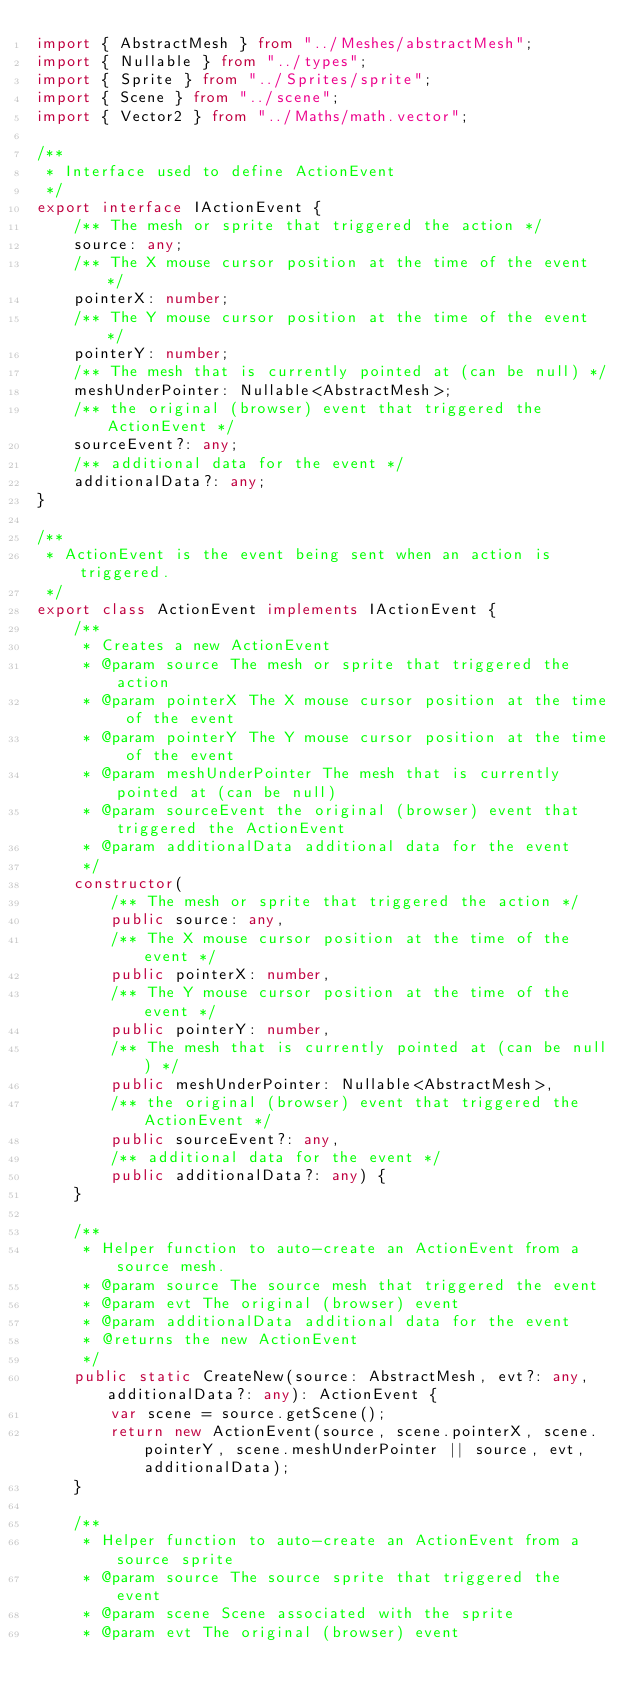Convert code to text. <code><loc_0><loc_0><loc_500><loc_500><_TypeScript_>import { AbstractMesh } from "../Meshes/abstractMesh";
import { Nullable } from "../types";
import { Sprite } from "../Sprites/sprite";
import { Scene } from "../scene";
import { Vector2 } from "../Maths/math.vector";

/**
 * Interface used to define ActionEvent
 */
export interface IActionEvent {
    /** The mesh or sprite that triggered the action */
    source: any;
    /** The X mouse cursor position at the time of the event */
    pointerX: number;
    /** The Y mouse cursor position at the time of the event */
    pointerY: number;
    /** The mesh that is currently pointed at (can be null) */
    meshUnderPointer: Nullable<AbstractMesh>;
    /** the original (browser) event that triggered the ActionEvent */
    sourceEvent?: any;
    /** additional data for the event */
    additionalData?: any;
}

/**
 * ActionEvent is the event being sent when an action is triggered.
 */
export class ActionEvent implements IActionEvent {
    /**
     * Creates a new ActionEvent
     * @param source The mesh or sprite that triggered the action
     * @param pointerX The X mouse cursor position at the time of the event
     * @param pointerY The Y mouse cursor position at the time of the event
     * @param meshUnderPointer The mesh that is currently pointed at (can be null)
     * @param sourceEvent the original (browser) event that triggered the ActionEvent
     * @param additionalData additional data for the event
     */
    constructor(
        /** The mesh or sprite that triggered the action */
        public source: any,
        /** The X mouse cursor position at the time of the event */
        public pointerX: number,
        /** The Y mouse cursor position at the time of the event */
        public pointerY: number,
        /** The mesh that is currently pointed at (can be null) */
        public meshUnderPointer: Nullable<AbstractMesh>,
        /** the original (browser) event that triggered the ActionEvent */
        public sourceEvent?: any,
        /** additional data for the event */
        public additionalData?: any) {
    }

    /**
     * Helper function to auto-create an ActionEvent from a source mesh.
     * @param source The source mesh that triggered the event
     * @param evt The original (browser) event
     * @param additionalData additional data for the event
     * @returns the new ActionEvent
     */
    public static CreateNew(source: AbstractMesh, evt?: any, additionalData?: any): ActionEvent {
        var scene = source.getScene();
        return new ActionEvent(source, scene.pointerX, scene.pointerY, scene.meshUnderPointer || source, evt, additionalData);
    }

    /**
     * Helper function to auto-create an ActionEvent from a source sprite
     * @param source The source sprite that triggered the event
     * @param scene Scene associated with the sprite
     * @param evt The original (browser) event</code> 